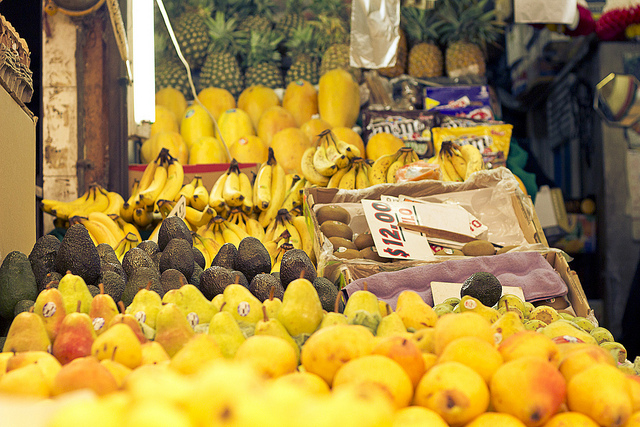Read all the text in this image. $12.00 m 